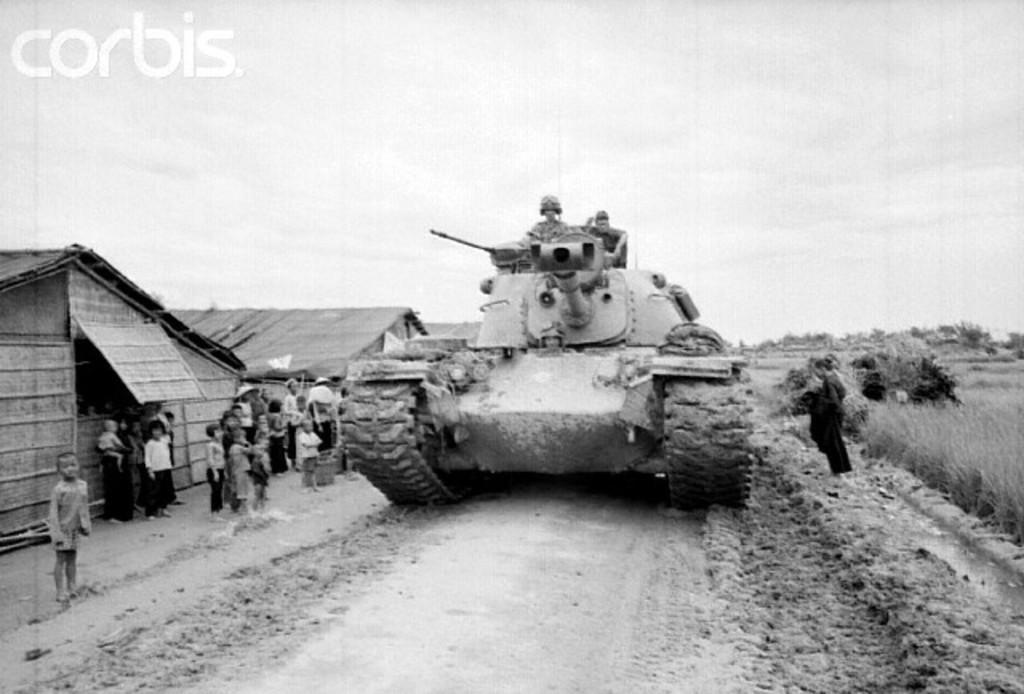How would you summarize this image in a sentence or two? This is a black and white image there is a vehicle, on the left side there are people standing and there are houses, on the top left there is some text. 